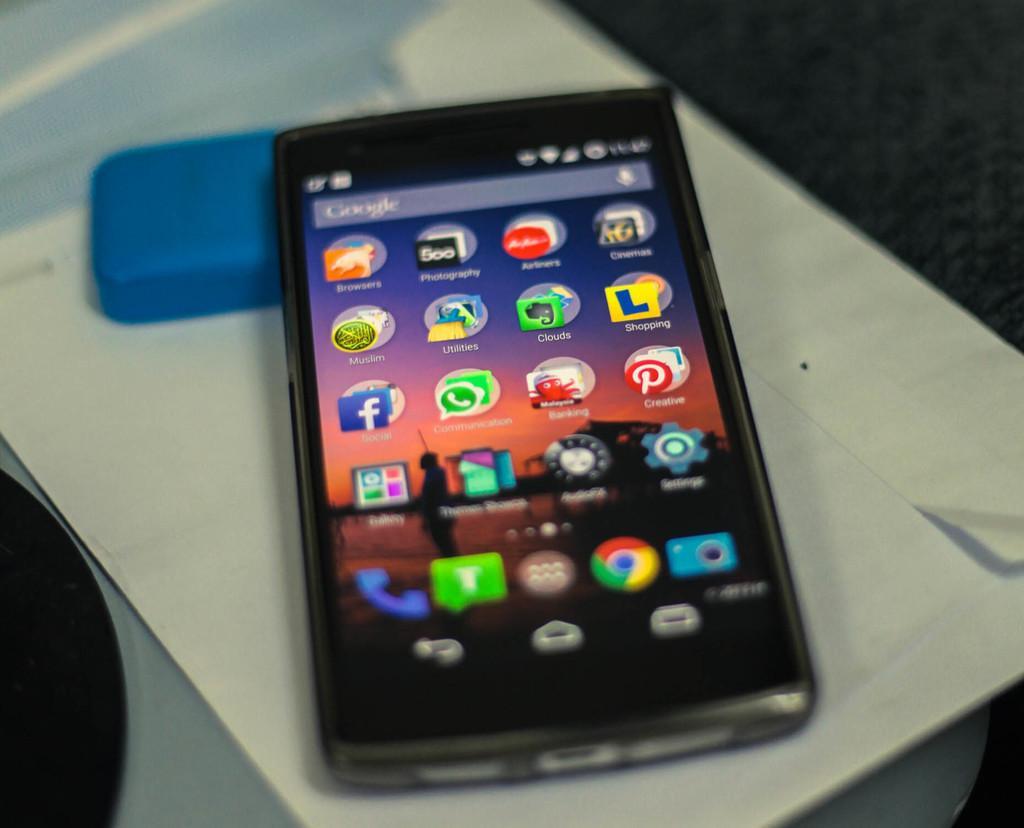How would you summarize this image in a sentence or two? In this image we can see a mobile placed on a paper. 